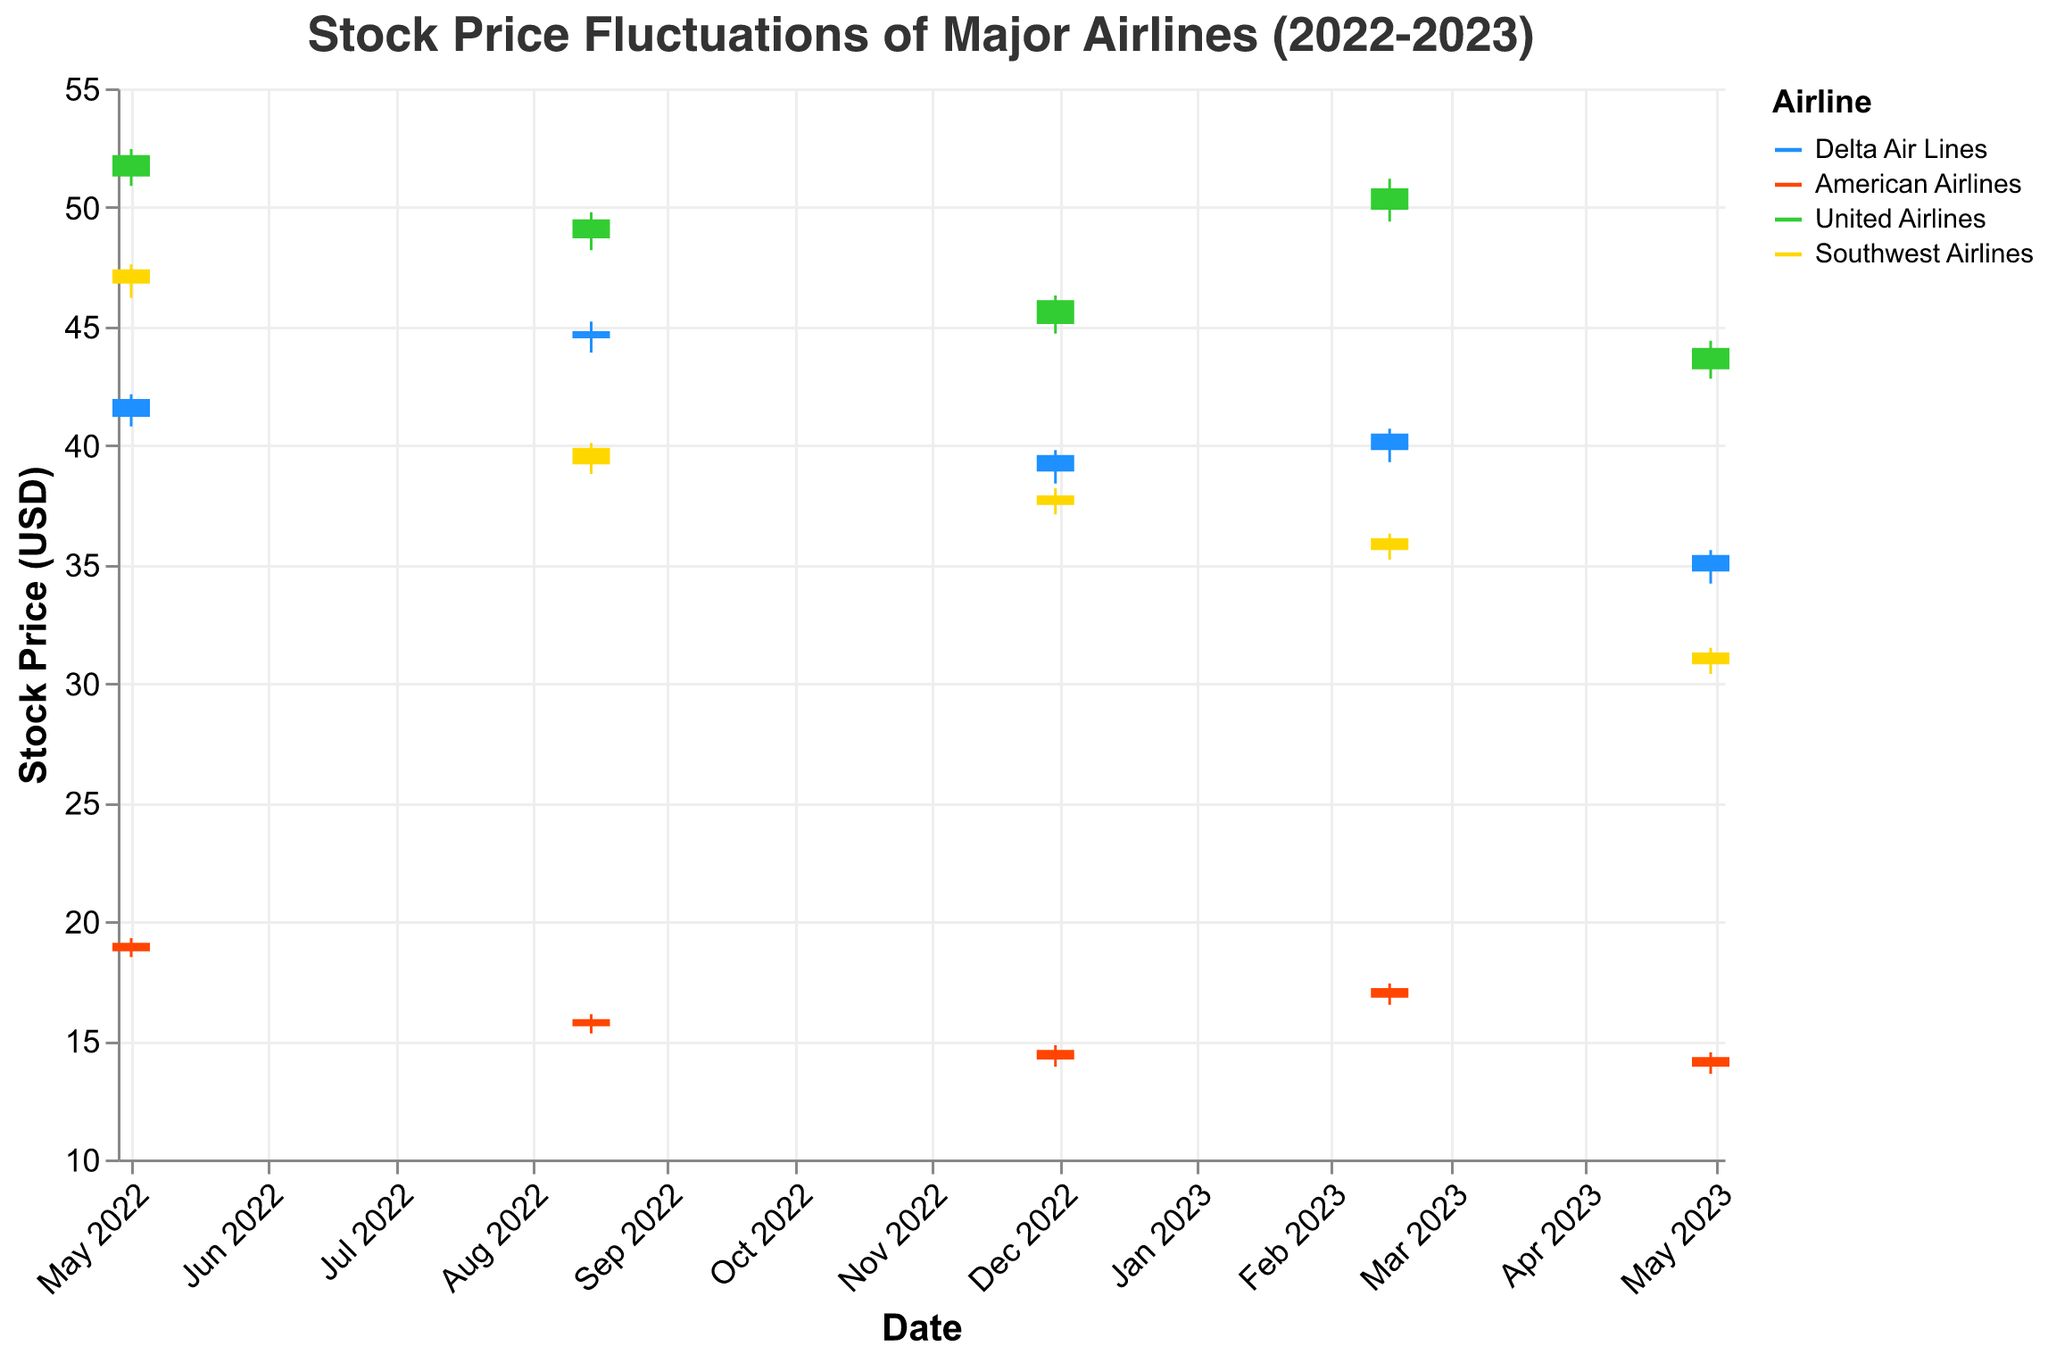How many airlines are represented in this chart? There are different colors representing different airlines in the chart legend. Four airlines are represented: Delta Air Lines, American Airlines, United Airlines, and Southwest Airlines.
Answer: Four What is the highest closing price for Delta Air Lines over the given dates? By checking the data for Delta Air Lines, we can see the highest closing prices on each date: 41.95 on 2022-05-01, 44.80 on 2022-08-15, 39.60 on 2022-11-30, 40.50 on 2023-02-15, and 35.40 on 2023-04-30. The highest of these is 44.80 on 2022-08-15.
Answer: 44.80 Which airline had the lowest opening price on 2023-04-30? We compare the opening prices on 2023-04-30 for each airline: Delta Air Lines: 34.70, American Airlines: 13.90, United Airlines: 43.20, Southwest Airlines: 30.80. The lowest opening price is 13.90 for American Airlines.
Answer: American Airlines On which date did United Airlines have the highest closing price, and what was it? By examining the closing prices for United Airlines, the highest closing prices on each date are: 52.20 on 2022-05-01, 49.50 on 2022-08-15, 46.10 on 2022-11-30, 50.80 on 2023-02-15, and 44.10 on 2023-04-30. The highest price is 52.20 on 2022-05-01.
Answer: 2022-05-01, 52.20 Which airline had the highest volatility (difference between high and low prices) on 2022-11-30, and what was the difference? To find the highest volatility, we calculate the difference between high and low prices for each airline on 2022-11-30: Delta Air Lines: 39.80 - 38.40 = 1.40, American Airlines: 14.80 - 13.90 = 0.90, United Airlines: 46.30 - 44.70 = 1.60, Southwest Airlines: 38.20 - 37.10 = 1.10. The highest volatility is for United Airlines with a difference of 1.60.
Answer: United Airlines, 1.60 What was the average closing price for Southwest Airlines across all dates? We have Southwest Airlines' closing prices: 47.40, 39.90, 37.90, 36.10, 31.30. Adding them gives 47.40 + 39.90 + 37.90 + 36.10 + 31.30 = 192.60. Dividing by 5, we get the average: 192.60 / 5 = 38.52.
Answer: 38.52 